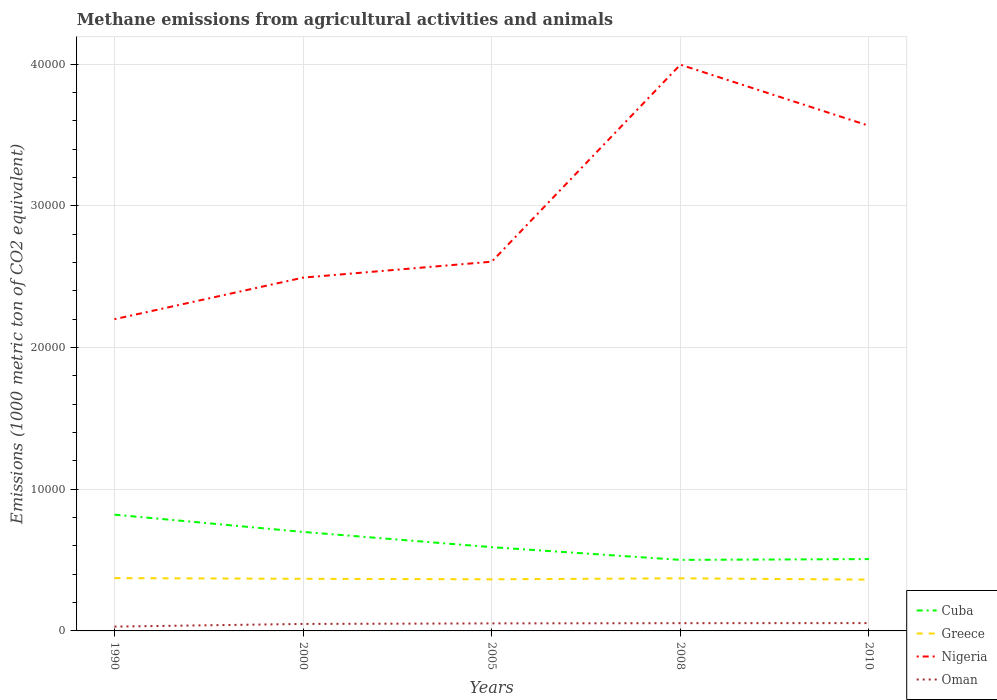How many different coloured lines are there?
Keep it short and to the point. 4. Across all years, what is the maximum amount of methane emitted in Greece?
Keep it short and to the point. 3622.4. In which year was the amount of methane emitted in Oman maximum?
Provide a succinct answer. 1990. What is the total amount of methane emitted in Cuba in the graph?
Your answer should be compact. 1074.5. What is the difference between the highest and the second highest amount of methane emitted in Cuba?
Give a very brief answer. 3192.5. What is the difference between the highest and the lowest amount of methane emitted in Nigeria?
Offer a very short reply. 2. How many lines are there?
Make the answer very short. 4. How many years are there in the graph?
Ensure brevity in your answer.  5. Are the values on the major ticks of Y-axis written in scientific E-notation?
Provide a succinct answer. No. Where does the legend appear in the graph?
Your answer should be very brief. Bottom right. How are the legend labels stacked?
Make the answer very short. Vertical. What is the title of the graph?
Ensure brevity in your answer.  Methane emissions from agricultural activities and animals. Does "Heavily indebted poor countries" appear as one of the legend labels in the graph?
Provide a succinct answer. No. What is the label or title of the Y-axis?
Ensure brevity in your answer.  Emissions (1000 metric ton of CO2 equivalent). What is the Emissions (1000 metric ton of CO2 equivalent) of Cuba in 1990?
Your answer should be very brief. 8207.5. What is the Emissions (1000 metric ton of CO2 equivalent) in Greece in 1990?
Offer a terse response. 3728.5. What is the Emissions (1000 metric ton of CO2 equivalent) of Nigeria in 1990?
Offer a very short reply. 2.20e+04. What is the Emissions (1000 metric ton of CO2 equivalent) in Oman in 1990?
Provide a succinct answer. 305.6. What is the Emissions (1000 metric ton of CO2 equivalent) of Cuba in 2000?
Offer a very short reply. 6988.3. What is the Emissions (1000 metric ton of CO2 equivalent) in Greece in 2000?
Your answer should be very brief. 3679.3. What is the Emissions (1000 metric ton of CO2 equivalent) in Nigeria in 2000?
Ensure brevity in your answer.  2.49e+04. What is the Emissions (1000 metric ton of CO2 equivalent) of Oman in 2000?
Your answer should be very brief. 493.2. What is the Emissions (1000 metric ton of CO2 equivalent) in Cuba in 2005?
Offer a terse response. 5913.8. What is the Emissions (1000 metric ton of CO2 equivalent) in Greece in 2005?
Provide a short and direct response. 3644.6. What is the Emissions (1000 metric ton of CO2 equivalent) of Nigeria in 2005?
Make the answer very short. 2.61e+04. What is the Emissions (1000 metric ton of CO2 equivalent) of Oman in 2005?
Your response must be concise. 531.8. What is the Emissions (1000 metric ton of CO2 equivalent) in Cuba in 2008?
Offer a very short reply. 5015. What is the Emissions (1000 metric ton of CO2 equivalent) in Greece in 2008?
Your answer should be compact. 3714.1. What is the Emissions (1000 metric ton of CO2 equivalent) in Nigeria in 2008?
Your answer should be compact. 4.00e+04. What is the Emissions (1000 metric ton of CO2 equivalent) in Oman in 2008?
Your answer should be compact. 546.4. What is the Emissions (1000 metric ton of CO2 equivalent) of Cuba in 2010?
Provide a short and direct response. 5070.2. What is the Emissions (1000 metric ton of CO2 equivalent) in Greece in 2010?
Provide a short and direct response. 3622.4. What is the Emissions (1000 metric ton of CO2 equivalent) of Nigeria in 2010?
Provide a succinct answer. 3.57e+04. What is the Emissions (1000 metric ton of CO2 equivalent) in Oman in 2010?
Offer a terse response. 551.8. Across all years, what is the maximum Emissions (1000 metric ton of CO2 equivalent) of Cuba?
Make the answer very short. 8207.5. Across all years, what is the maximum Emissions (1000 metric ton of CO2 equivalent) of Greece?
Offer a very short reply. 3728.5. Across all years, what is the maximum Emissions (1000 metric ton of CO2 equivalent) of Nigeria?
Ensure brevity in your answer.  4.00e+04. Across all years, what is the maximum Emissions (1000 metric ton of CO2 equivalent) of Oman?
Keep it short and to the point. 551.8. Across all years, what is the minimum Emissions (1000 metric ton of CO2 equivalent) in Cuba?
Your response must be concise. 5015. Across all years, what is the minimum Emissions (1000 metric ton of CO2 equivalent) in Greece?
Offer a very short reply. 3622.4. Across all years, what is the minimum Emissions (1000 metric ton of CO2 equivalent) of Nigeria?
Your answer should be compact. 2.20e+04. Across all years, what is the minimum Emissions (1000 metric ton of CO2 equivalent) in Oman?
Your answer should be compact. 305.6. What is the total Emissions (1000 metric ton of CO2 equivalent) of Cuba in the graph?
Your answer should be very brief. 3.12e+04. What is the total Emissions (1000 metric ton of CO2 equivalent) in Greece in the graph?
Offer a terse response. 1.84e+04. What is the total Emissions (1000 metric ton of CO2 equivalent) in Nigeria in the graph?
Your answer should be compact. 1.49e+05. What is the total Emissions (1000 metric ton of CO2 equivalent) in Oman in the graph?
Make the answer very short. 2428.8. What is the difference between the Emissions (1000 metric ton of CO2 equivalent) in Cuba in 1990 and that in 2000?
Provide a short and direct response. 1219.2. What is the difference between the Emissions (1000 metric ton of CO2 equivalent) of Greece in 1990 and that in 2000?
Ensure brevity in your answer.  49.2. What is the difference between the Emissions (1000 metric ton of CO2 equivalent) in Nigeria in 1990 and that in 2000?
Offer a very short reply. -2935.6. What is the difference between the Emissions (1000 metric ton of CO2 equivalent) in Oman in 1990 and that in 2000?
Provide a succinct answer. -187.6. What is the difference between the Emissions (1000 metric ton of CO2 equivalent) of Cuba in 1990 and that in 2005?
Ensure brevity in your answer.  2293.7. What is the difference between the Emissions (1000 metric ton of CO2 equivalent) in Greece in 1990 and that in 2005?
Offer a very short reply. 83.9. What is the difference between the Emissions (1000 metric ton of CO2 equivalent) in Nigeria in 1990 and that in 2005?
Offer a terse response. -4059.4. What is the difference between the Emissions (1000 metric ton of CO2 equivalent) in Oman in 1990 and that in 2005?
Your answer should be compact. -226.2. What is the difference between the Emissions (1000 metric ton of CO2 equivalent) in Cuba in 1990 and that in 2008?
Keep it short and to the point. 3192.5. What is the difference between the Emissions (1000 metric ton of CO2 equivalent) in Greece in 1990 and that in 2008?
Give a very brief answer. 14.4. What is the difference between the Emissions (1000 metric ton of CO2 equivalent) in Nigeria in 1990 and that in 2008?
Your answer should be very brief. -1.80e+04. What is the difference between the Emissions (1000 metric ton of CO2 equivalent) of Oman in 1990 and that in 2008?
Keep it short and to the point. -240.8. What is the difference between the Emissions (1000 metric ton of CO2 equivalent) of Cuba in 1990 and that in 2010?
Your response must be concise. 3137.3. What is the difference between the Emissions (1000 metric ton of CO2 equivalent) of Greece in 1990 and that in 2010?
Offer a very short reply. 106.1. What is the difference between the Emissions (1000 metric ton of CO2 equivalent) in Nigeria in 1990 and that in 2010?
Your answer should be very brief. -1.37e+04. What is the difference between the Emissions (1000 metric ton of CO2 equivalent) in Oman in 1990 and that in 2010?
Your answer should be very brief. -246.2. What is the difference between the Emissions (1000 metric ton of CO2 equivalent) of Cuba in 2000 and that in 2005?
Your answer should be compact. 1074.5. What is the difference between the Emissions (1000 metric ton of CO2 equivalent) of Greece in 2000 and that in 2005?
Provide a short and direct response. 34.7. What is the difference between the Emissions (1000 metric ton of CO2 equivalent) of Nigeria in 2000 and that in 2005?
Make the answer very short. -1123.8. What is the difference between the Emissions (1000 metric ton of CO2 equivalent) in Oman in 2000 and that in 2005?
Make the answer very short. -38.6. What is the difference between the Emissions (1000 metric ton of CO2 equivalent) of Cuba in 2000 and that in 2008?
Your response must be concise. 1973.3. What is the difference between the Emissions (1000 metric ton of CO2 equivalent) in Greece in 2000 and that in 2008?
Ensure brevity in your answer.  -34.8. What is the difference between the Emissions (1000 metric ton of CO2 equivalent) of Nigeria in 2000 and that in 2008?
Offer a terse response. -1.50e+04. What is the difference between the Emissions (1000 metric ton of CO2 equivalent) in Oman in 2000 and that in 2008?
Make the answer very short. -53.2. What is the difference between the Emissions (1000 metric ton of CO2 equivalent) in Cuba in 2000 and that in 2010?
Provide a short and direct response. 1918.1. What is the difference between the Emissions (1000 metric ton of CO2 equivalent) in Greece in 2000 and that in 2010?
Offer a very short reply. 56.9. What is the difference between the Emissions (1000 metric ton of CO2 equivalent) in Nigeria in 2000 and that in 2010?
Make the answer very short. -1.07e+04. What is the difference between the Emissions (1000 metric ton of CO2 equivalent) of Oman in 2000 and that in 2010?
Offer a terse response. -58.6. What is the difference between the Emissions (1000 metric ton of CO2 equivalent) of Cuba in 2005 and that in 2008?
Give a very brief answer. 898.8. What is the difference between the Emissions (1000 metric ton of CO2 equivalent) of Greece in 2005 and that in 2008?
Provide a succinct answer. -69.5. What is the difference between the Emissions (1000 metric ton of CO2 equivalent) of Nigeria in 2005 and that in 2008?
Your response must be concise. -1.39e+04. What is the difference between the Emissions (1000 metric ton of CO2 equivalent) of Oman in 2005 and that in 2008?
Your response must be concise. -14.6. What is the difference between the Emissions (1000 metric ton of CO2 equivalent) of Cuba in 2005 and that in 2010?
Give a very brief answer. 843.6. What is the difference between the Emissions (1000 metric ton of CO2 equivalent) of Greece in 2005 and that in 2010?
Your response must be concise. 22.2. What is the difference between the Emissions (1000 metric ton of CO2 equivalent) of Nigeria in 2005 and that in 2010?
Your answer should be very brief. -9593.8. What is the difference between the Emissions (1000 metric ton of CO2 equivalent) in Cuba in 2008 and that in 2010?
Offer a terse response. -55.2. What is the difference between the Emissions (1000 metric ton of CO2 equivalent) of Greece in 2008 and that in 2010?
Your response must be concise. 91.7. What is the difference between the Emissions (1000 metric ton of CO2 equivalent) of Nigeria in 2008 and that in 2010?
Your response must be concise. 4315.8. What is the difference between the Emissions (1000 metric ton of CO2 equivalent) of Cuba in 1990 and the Emissions (1000 metric ton of CO2 equivalent) of Greece in 2000?
Offer a terse response. 4528.2. What is the difference between the Emissions (1000 metric ton of CO2 equivalent) in Cuba in 1990 and the Emissions (1000 metric ton of CO2 equivalent) in Nigeria in 2000?
Give a very brief answer. -1.67e+04. What is the difference between the Emissions (1000 metric ton of CO2 equivalent) of Cuba in 1990 and the Emissions (1000 metric ton of CO2 equivalent) of Oman in 2000?
Keep it short and to the point. 7714.3. What is the difference between the Emissions (1000 metric ton of CO2 equivalent) in Greece in 1990 and the Emissions (1000 metric ton of CO2 equivalent) in Nigeria in 2000?
Keep it short and to the point. -2.12e+04. What is the difference between the Emissions (1000 metric ton of CO2 equivalent) in Greece in 1990 and the Emissions (1000 metric ton of CO2 equivalent) in Oman in 2000?
Provide a succinct answer. 3235.3. What is the difference between the Emissions (1000 metric ton of CO2 equivalent) in Nigeria in 1990 and the Emissions (1000 metric ton of CO2 equivalent) in Oman in 2000?
Provide a short and direct response. 2.15e+04. What is the difference between the Emissions (1000 metric ton of CO2 equivalent) in Cuba in 1990 and the Emissions (1000 metric ton of CO2 equivalent) in Greece in 2005?
Make the answer very short. 4562.9. What is the difference between the Emissions (1000 metric ton of CO2 equivalent) in Cuba in 1990 and the Emissions (1000 metric ton of CO2 equivalent) in Nigeria in 2005?
Your answer should be very brief. -1.79e+04. What is the difference between the Emissions (1000 metric ton of CO2 equivalent) of Cuba in 1990 and the Emissions (1000 metric ton of CO2 equivalent) of Oman in 2005?
Provide a succinct answer. 7675.7. What is the difference between the Emissions (1000 metric ton of CO2 equivalent) in Greece in 1990 and the Emissions (1000 metric ton of CO2 equivalent) in Nigeria in 2005?
Make the answer very short. -2.23e+04. What is the difference between the Emissions (1000 metric ton of CO2 equivalent) in Greece in 1990 and the Emissions (1000 metric ton of CO2 equivalent) in Oman in 2005?
Ensure brevity in your answer.  3196.7. What is the difference between the Emissions (1000 metric ton of CO2 equivalent) of Nigeria in 1990 and the Emissions (1000 metric ton of CO2 equivalent) of Oman in 2005?
Offer a very short reply. 2.15e+04. What is the difference between the Emissions (1000 metric ton of CO2 equivalent) of Cuba in 1990 and the Emissions (1000 metric ton of CO2 equivalent) of Greece in 2008?
Provide a short and direct response. 4493.4. What is the difference between the Emissions (1000 metric ton of CO2 equivalent) of Cuba in 1990 and the Emissions (1000 metric ton of CO2 equivalent) of Nigeria in 2008?
Offer a terse response. -3.18e+04. What is the difference between the Emissions (1000 metric ton of CO2 equivalent) in Cuba in 1990 and the Emissions (1000 metric ton of CO2 equivalent) in Oman in 2008?
Your answer should be very brief. 7661.1. What is the difference between the Emissions (1000 metric ton of CO2 equivalent) of Greece in 1990 and the Emissions (1000 metric ton of CO2 equivalent) of Nigeria in 2008?
Keep it short and to the point. -3.62e+04. What is the difference between the Emissions (1000 metric ton of CO2 equivalent) in Greece in 1990 and the Emissions (1000 metric ton of CO2 equivalent) in Oman in 2008?
Provide a succinct answer. 3182.1. What is the difference between the Emissions (1000 metric ton of CO2 equivalent) of Nigeria in 1990 and the Emissions (1000 metric ton of CO2 equivalent) of Oman in 2008?
Provide a succinct answer. 2.15e+04. What is the difference between the Emissions (1000 metric ton of CO2 equivalent) of Cuba in 1990 and the Emissions (1000 metric ton of CO2 equivalent) of Greece in 2010?
Ensure brevity in your answer.  4585.1. What is the difference between the Emissions (1000 metric ton of CO2 equivalent) in Cuba in 1990 and the Emissions (1000 metric ton of CO2 equivalent) in Nigeria in 2010?
Provide a short and direct response. -2.75e+04. What is the difference between the Emissions (1000 metric ton of CO2 equivalent) in Cuba in 1990 and the Emissions (1000 metric ton of CO2 equivalent) in Oman in 2010?
Your response must be concise. 7655.7. What is the difference between the Emissions (1000 metric ton of CO2 equivalent) in Greece in 1990 and the Emissions (1000 metric ton of CO2 equivalent) in Nigeria in 2010?
Your answer should be compact. -3.19e+04. What is the difference between the Emissions (1000 metric ton of CO2 equivalent) of Greece in 1990 and the Emissions (1000 metric ton of CO2 equivalent) of Oman in 2010?
Give a very brief answer. 3176.7. What is the difference between the Emissions (1000 metric ton of CO2 equivalent) of Nigeria in 1990 and the Emissions (1000 metric ton of CO2 equivalent) of Oman in 2010?
Keep it short and to the point. 2.15e+04. What is the difference between the Emissions (1000 metric ton of CO2 equivalent) of Cuba in 2000 and the Emissions (1000 metric ton of CO2 equivalent) of Greece in 2005?
Keep it short and to the point. 3343.7. What is the difference between the Emissions (1000 metric ton of CO2 equivalent) of Cuba in 2000 and the Emissions (1000 metric ton of CO2 equivalent) of Nigeria in 2005?
Your answer should be compact. -1.91e+04. What is the difference between the Emissions (1000 metric ton of CO2 equivalent) in Cuba in 2000 and the Emissions (1000 metric ton of CO2 equivalent) in Oman in 2005?
Your answer should be compact. 6456.5. What is the difference between the Emissions (1000 metric ton of CO2 equivalent) in Greece in 2000 and the Emissions (1000 metric ton of CO2 equivalent) in Nigeria in 2005?
Your answer should be compact. -2.24e+04. What is the difference between the Emissions (1000 metric ton of CO2 equivalent) in Greece in 2000 and the Emissions (1000 metric ton of CO2 equivalent) in Oman in 2005?
Give a very brief answer. 3147.5. What is the difference between the Emissions (1000 metric ton of CO2 equivalent) of Nigeria in 2000 and the Emissions (1000 metric ton of CO2 equivalent) of Oman in 2005?
Provide a succinct answer. 2.44e+04. What is the difference between the Emissions (1000 metric ton of CO2 equivalent) in Cuba in 2000 and the Emissions (1000 metric ton of CO2 equivalent) in Greece in 2008?
Make the answer very short. 3274.2. What is the difference between the Emissions (1000 metric ton of CO2 equivalent) of Cuba in 2000 and the Emissions (1000 metric ton of CO2 equivalent) of Nigeria in 2008?
Offer a very short reply. -3.30e+04. What is the difference between the Emissions (1000 metric ton of CO2 equivalent) in Cuba in 2000 and the Emissions (1000 metric ton of CO2 equivalent) in Oman in 2008?
Your answer should be very brief. 6441.9. What is the difference between the Emissions (1000 metric ton of CO2 equivalent) of Greece in 2000 and the Emissions (1000 metric ton of CO2 equivalent) of Nigeria in 2008?
Make the answer very short. -3.63e+04. What is the difference between the Emissions (1000 metric ton of CO2 equivalent) of Greece in 2000 and the Emissions (1000 metric ton of CO2 equivalent) of Oman in 2008?
Keep it short and to the point. 3132.9. What is the difference between the Emissions (1000 metric ton of CO2 equivalent) in Nigeria in 2000 and the Emissions (1000 metric ton of CO2 equivalent) in Oman in 2008?
Your answer should be very brief. 2.44e+04. What is the difference between the Emissions (1000 metric ton of CO2 equivalent) of Cuba in 2000 and the Emissions (1000 metric ton of CO2 equivalent) of Greece in 2010?
Your response must be concise. 3365.9. What is the difference between the Emissions (1000 metric ton of CO2 equivalent) of Cuba in 2000 and the Emissions (1000 metric ton of CO2 equivalent) of Nigeria in 2010?
Your response must be concise. -2.87e+04. What is the difference between the Emissions (1000 metric ton of CO2 equivalent) of Cuba in 2000 and the Emissions (1000 metric ton of CO2 equivalent) of Oman in 2010?
Offer a very short reply. 6436.5. What is the difference between the Emissions (1000 metric ton of CO2 equivalent) of Greece in 2000 and the Emissions (1000 metric ton of CO2 equivalent) of Nigeria in 2010?
Make the answer very short. -3.20e+04. What is the difference between the Emissions (1000 metric ton of CO2 equivalent) in Greece in 2000 and the Emissions (1000 metric ton of CO2 equivalent) in Oman in 2010?
Give a very brief answer. 3127.5. What is the difference between the Emissions (1000 metric ton of CO2 equivalent) in Nigeria in 2000 and the Emissions (1000 metric ton of CO2 equivalent) in Oman in 2010?
Make the answer very short. 2.44e+04. What is the difference between the Emissions (1000 metric ton of CO2 equivalent) in Cuba in 2005 and the Emissions (1000 metric ton of CO2 equivalent) in Greece in 2008?
Give a very brief answer. 2199.7. What is the difference between the Emissions (1000 metric ton of CO2 equivalent) in Cuba in 2005 and the Emissions (1000 metric ton of CO2 equivalent) in Nigeria in 2008?
Your answer should be compact. -3.41e+04. What is the difference between the Emissions (1000 metric ton of CO2 equivalent) of Cuba in 2005 and the Emissions (1000 metric ton of CO2 equivalent) of Oman in 2008?
Offer a very short reply. 5367.4. What is the difference between the Emissions (1000 metric ton of CO2 equivalent) of Greece in 2005 and the Emissions (1000 metric ton of CO2 equivalent) of Nigeria in 2008?
Your answer should be compact. -3.63e+04. What is the difference between the Emissions (1000 metric ton of CO2 equivalent) in Greece in 2005 and the Emissions (1000 metric ton of CO2 equivalent) in Oman in 2008?
Your answer should be compact. 3098.2. What is the difference between the Emissions (1000 metric ton of CO2 equivalent) of Nigeria in 2005 and the Emissions (1000 metric ton of CO2 equivalent) of Oman in 2008?
Make the answer very short. 2.55e+04. What is the difference between the Emissions (1000 metric ton of CO2 equivalent) of Cuba in 2005 and the Emissions (1000 metric ton of CO2 equivalent) of Greece in 2010?
Ensure brevity in your answer.  2291.4. What is the difference between the Emissions (1000 metric ton of CO2 equivalent) in Cuba in 2005 and the Emissions (1000 metric ton of CO2 equivalent) in Nigeria in 2010?
Your response must be concise. -2.97e+04. What is the difference between the Emissions (1000 metric ton of CO2 equivalent) in Cuba in 2005 and the Emissions (1000 metric ton of CO2 equivalent) in Oman in 2010?
Offer a very short reply. 5362. What is the difference between the Emissions (1000 metric ton of CO2 equivalent) in Greece in 2005 and the Emissions (1000 metric ton of CO2 equivalent) in Nigeria in 2010?
Give a very brief answer. -3.20e+04. What is the difference between the Emissions (1000 metric ton of CO2 equivalent) of Greece in 2005 and the Emissions (1000 metric ton of CO2 equivalent) of Oman in 2010?
Give a very brief answer. 3092.8. What is the difference between the Emissions (1000 metric ton of CO2 equivalent) in Nigeria in 2005 and the Emissions (1000 metric ton of CO2 equivalent) in Oman in 2010?
Make the answer very short. 2.55e+04. What is the difference between the Emissions (1000 metric ton of CO2 equivalent) of Cuba in 2008 and the Emissions (1000 metric ton of CO2 equivalent) of Greece in 2010?
Your answer should be very brief. 1392.6. What is the difference between the Emissions (1000 metric ton of CO2 equivalent) in Cuba in 2008 and the Emissions (1000 metric ton of CO2 equivalent) in Nigeria in 2010?
Offer a very short reply. -3.06e+04. What is the difference between the Emissions (1000 metric ton of CO2 equivalent) of Cuba in 2008 and the Emissions (1000 metric ton of CO2 equivalent) of Oman in 2010?
Your response must be concise. 4463.2. What is the difference between the Emissions (1000 metric ton of CO2 equivalent) in Greece in 2008 and the Emissions (1000 metric ton of CO2 equivalent) in Nigeria in 2010?
Your response must be concise. -3.19e+04. What is the difference between the Emissions (1000 metric ton of CO2 equivalent) in Greece in 2008 and the Emissions (1000 metric ton of CO2 equivalent) in Oman in 2010?
Ensure brevity in your answer.  3162.3. What is the difference between the Emissions (1000 metric ton of CO2 equivalent) in Nigeria in 2008 and the Emissions (1000 metric ton of CO2 equivalent) in Oman in 2010?
Offer a terse response. 3.94e+04. What is the average Emissions (1000 metric ton of CO2 equivalent) in Cuba per year?
Your answer should be compact. 6238.96. What is the average Emissions (1000 metric ton of CO2 equivalent) of Greece per year?
Your response must be concise. 3677.78. What is the average Emissions (1000 metric ton of CO2 equivalent) in Nigeria per year?
Offer a very short reply. 2.97e+04. What is the average Emissions (1000 metric ton of CO2 equivalent) in Oman per year?
Provide a short and direct response. 485.76. In the year 1990, what is the difference between the Emissions (1000 metric ton of CO2 equivalent) in Cuba and Emissions (1000 metric ton of CO2 equivalent) in Greece?
Ensure brevity in your answer.  4479. In the year 1990, what is the difference between the Emissions (1000 metric ton of CO2 equivalent) in Cuba and Emissions (1000 metric ton of CO2 equivalent) in Nigeria?
Your answer should be compact. -1.38e+04. In the year 1990, what is the difference between the Emissions (1000 metric ton of CO2 equivalent) of Cuba and Emissions (1000 metric ton of CO2 equivalent) of Oman?
Make the answer very short. 7901.9. In the year 1990, what is the difference between the Emissions (1000 metric ton of CO2 equivalent) of Greece and Emissions (1000 metric ton of CO2 equivalent) of Nigeria?
Provide a succinct answer. -1.83e+04. In the year 1990, what is the difference between the Emissions (1000 metric ton of CO2 equivalent) of Greece and Emissions (1000 metric ton of CO2 equivalent) of Oman?
Make the answer very short. 3422.9. In the year 1990, what is the difference between the Emissions (1000 metric ton of CO2 equivalent) in Nigeria and Emissions (1000 metric ton of CO2 equivalent) in Oman?
Provide a succinct answer. 2.17e+04. In the year 2000, what is the difference between the Emissions (1000 metric ton of CO2 equivalent) of Cuba and Emissions (1000 metric ton of CO2 equivalent) of Greece?
Ensure brevity in your answer.  3309. In the year 2000, what is the difference between the Emissions (1000 metric ton of CO2 equivalent) in Cuba and Emissions (1000 metric ton of CO2 equivalent) in Nigeria?
Your answer should be very brief. -1.80e+04. In the year 2000, what is the difference between the Emissions (1000 metric ton of CO2 equivalent) of Cuba and Emissions (1000 metric ton of CO2 equivalent) of Oman?
Make the answer very short. 6495.1. In the year 2000, what is the difference between the Emissions (1000 metric ton of CO2 equivalent) in Greece and Emissions (1000 metric ton of CO2 equivalent) in Nigeria?
Your response must be concise. -2.13e+04. In the year 2000, what is the difference between the Emissions (1000 metric ton of CO2 equivalent) in Greece and Emissions (1000 metric ton of CO2 equivalent) in Oman?
Make the answer very short. 3186.1. In the year 2000, what is the difference between the Emissions (1000 metric ton of CO2 equivalent) in Nigeria and Emissions (1000 metric ton of CO2 equivalent) in Oman?
Make the answer very short. 2.44e+04. In the year 2005, what is the difference between the Emissions (1000 metric ton of CO2 equivalent) in Cuba and Emissions (1000 metric ton of CO2 equivalent) in Greece?
Provide a succinct answer. 2269.2. In the year 2005, what is the difference between the Emissions (1000 metric ton of CO2 equivalent) in Cuba and Emissions (1000 metric ton of CO2 equivalent) in Nigeria?
Offer a very short reply. -2.02e+04. In the year 2005, what is the difference between the Emissions (1000 metric ton of CO2 equivalent) in Cuba and Emissions (1000 metric ton of CO2 equivalent) in Oman?
Ensure brevity in your answer.  5382. In the year 2005, what is the difference between the Emissions (1000 metric ton of CO2 equivalent) in Greece and Emissions (1000 metric ton of CO2 equivalent) in Nigeria?
Offer a very short reply. -2.24e+04. In the year 2005, what is the difference between the Emissions (1000 metric ton of CO2 equivalent) in Greece and Emissions (1000 metric ton of CO2 equivalent) in Oman?
Provide a succinct answer. 3112.8. In the year 2005, what is the difference between the Emissions (1000 metric ton of CO2 equivalent) in Nigeria and Emissions (1000 metric ton of CO2 equivalent) in Oman?
Offer a very short reply. 2.55e+04. In the year 2008, what is the difference between the Emissions (1000 metric ton of CO2 equivalent) of Cuba and Emissions (1000 metric ton of CO2 equivalent) of Greece?
Provide a short and direct response. 1300.9. In the year 2008, what is the difference between the Emissions (1000 metric ton of CO2 equivalent) of Cuba and Emissions (1000 metric ton of CO2 equivalent) of Nigeria?
Your response must be concise. -3.50e+04. In the year 2008, what is the difference between the Emissions (1000 metric ton of CO2 equivalent) in Cuba and Emissions (1000 metric ton of CO2 equivalent) in Oman?
Your answer should be compact. 4468.6. In the year 2008, what is the difference between the Emissions (1000 metric ton of CO2 equivalent) in Greece and Emissions (1000 metric ton of CO2 equivalent) in Nigeria?
Provide a short and direct response. -3.63e+04. In the year 2008, what is the difference between the Emissions (1000 metric ton of CO2 equivalent) of Greece and Emissions (1000 metric ton of CO2 equivalent) of Oman?
Offer a very short reply. 3167.7. In the year 2008, what is the difference between the Emissions (1000 metric ton of CO2 equivalent) of Nigeria and Emissions (1000 metric ton of CO2 equivalent) of Oman?
Provide a succinct answer. 3.94e+04. In the year 2010, what is the difference between the Emissions (1000 metric ton of CO2 equivalent) in Cuba and Emissions (1000 metric ton of CO2 equivalent) in Greece?
Ensure brevity in your answer.  1447.8. In the year 2010, what is the difference between the Emissions (1000 metric ton of CO2 equivalent) of Cuba and Emissions (1000 metric ton of CO2 equivalent) of Nigeria?
Your response must be concise. -3.06e+04. In the year 2010, what is the difference between the Emissions (1000 metric ton of CO2 equivalent) of Cuba and Emissions (1000 metric ton of CO2 equivalent) of Oman?
Your answer should be very brief. 4518.4. In the year 2010, what is the difference between the Emissions (1000 metric ton of CO2 equivalent) of Greece and Emissions (1000 metric ton of CO2 equivalent) of Nigeria?
Make the answer very short. -3.20e+04. In the year 2010, what is the difference between the Emissions (1000 metric ton of CO2 equivalent) in Greece and Emissions (1000 metric ton of CO2 equivalent) in Oman?
Offer a very short reply. 3070.6. In the year 2010, what is the difference between the Emissions (1000 metric ton of CO2 equivalent) of Nigeria and Emissions (1000 metric ton of CO2 equivalent) of Oman?
Your answer should be compact. 3.51e+04. What is the ratio of the Emissions (1000 metric ton of CO2 equivalent) in Cuba in 1990 to that in 2000?
Your answer should be compact. 1.17. What is the ratio of the Emissions (1000 metric ton of CO2 equivalent) in Greece in 1990 to that in 2000?
Offer a very short reply. 1.01. What is the ratio of the Emissions (1000 metric ton of CO2 equivalent) of Nigeria in 1990 to that in 2000?
Provide a short and direct response. 0.88. What is the ratio of the Emissions (1000 metric ton of CO2 equivalent) of Oman in 1990 to that in 2000?
Make the answer very short. 0.62. What is the ratio of the Emissions (1000 metric ton of CO2 equivalent) of Cuba in 1990 to that in 2005?
Provide a succinct answer. 1.39. What is the ratio of the Emissions (1000 metric ton of CO2 equivalent) of Greece in 1990 to that in 2005?
Keep it short and to the point. 1.02. What is the ratio of the Emissions (1000 metric ton of CO2 equivalent) of Nigeria in 1990 to that in 2005?
Provide a succinct answer. 0.84. What is the ratio of the Emissions (1000 metric ton of CO2 equivalent) in Oman in 1990 to that in 2005?
Offer a very short reply. 0.57. What is the ratio of the Emissions (1000 metric ton of CO2 equivalent) in Cuba in 1990 to that in 2008?
Provide a short and direct response. 1.64. What is the ratio of the Emissions (1000 metric ton of CO2 equivalent) of Nigeria in 1990 to that in 2008?
Make the answer very short. 0.55. What is the ratio of the Emissions (1000 metric ton of CO2 equivalent) in Oman in 1990 to that in 2008?
Provide a short and direct response. 0.56. What is the ratio of the Emissions (1000 metric ton of CO2 equivalent) in Cuba in 1990 to that in 2010?
Provide a short and direct response. 1.62. What is the ratio of the Emissions (1000 metric ton of CO2 equivalent) in Greece in 1990 to that in 2010?
Your answer should be very brief. 1.03. What is the ratio of the Emissions (1000 metric ton of CO2 equivalent) in Nigeria in 1990 to that in 2010?
Your answer should be very brief. 0.62. What is the ratio of the Emissions (1000 metric ton of CO2 equivalent) of Oman in 1990 to that in 2010?
Provide a succinct answer. 0.55. What is the ratio of the Emissions (1000 metric ton of CO2 equivalent) of Cuba in 2000 to that in 2005?
Ensure brevity in your answer.  1.18. What is the ratio of the Emissions (1000 metric ton of CO2 equivalent) of Greece in 2000 to that in 2005?
Make the answer very short. 1.01. What is the ratio of the Emissions (1000 metric ton of CO2 equivalent) of Nigeria in 2000 to that in 2005?
Provide a succinct answer. 0.96. What is the ratio of the Emissions (1000 metric ton of CO2 equivalent) in Oman in 2000 to that in 2005?
Keep it short and to the point. 0.93. What is the ratio of the Emissions (1000 metric ton of CO2 equivalent) of Cuba in 2000 to that in 2008?
Make the answer very short. 1.39. What is the ratio of the Emissions (1000 metric ton of CO2 equivalent) of Greece in 2000 to that in 2008?
Offer a very short reply. 0.99. What is the ratio of the Emissions (1000 metric ton of CO2 equivalent) of Nigeria in 2000 to that in 2008?
Provide a short and direct response. 0.62. What is the ratio of the Emissions (1000 metric ton of CO2 equivalent) in Oman in 2000 to that in 2008?
Give a very brief answer. 0.9. What is the ratio of the Emissions (1000 metric ton of CO2 equivalent) in Cuba in 2000 to that in 2010?
Offer a terse response. 1.38. What is the ratio of the Emissions (1000 metric ton of CO2 equivalent) of Greece in 2000 to that in 2010?
Give a very brief answer. 1.02. What is the ratio of the Emissions (1000 metric ton of CO2 equivalent) in Nigeria in 2000 to that in 2010?
Keep it short and to the point. 0.7. What is the ratio of the Emissions (1000 metric ton of CO2 equivalent) in Oman in 2000 to that in 2010?
Offer a very short reply. 0.89. What is the ratio of the Emissions (1000 metric ton of CO2 equivalent) of Cuba in 2005 to that in 2008?
Offer a terse response. 1.18. What is the ratio of the Emissions (1000 metric ton of CO2 equivalent) of Greece in 2005 to that in 2008?
Provide a short and direct response. 0.98. What is the ratio of the Emissions (1000 metric ton of CO2 equivalent) of Nigeria in 2005 to that in 2008?
Give a very brief answer. 0.65. What is the ratio of the Emissions (1000 metric ton of CO2 equivalent) of Oman in 2005 to that in 2008?
Your answer should be very brief. 0.97. What is the ratio of the Emissions (1000 metric ton of CO2 equivalent) in Cuba in 2005 to that in 2010?
Your answer should be compact. 1.17. What is the ratio of the Emissions (1000 metric ton of CO2 equivalent) of Nigeria in 2005 to that in 2010?
Your answer should be compact. 0.73. What is the ratio of the Emissions (1000 metric ton of CO2 equivalent) of Oman in 2005 to that in 2010?
Make the answer very short. 0.96. What is the ratio of the Emissions (1000 metric ton of CO2 equivalent) of Greece in 2008 to that in 2010?
Give a very brief answer. 1.03. What is the ratio of the Emissions (1000 metric ton of CO2 equivalent) of Nigeria in 2008 to that in 2010?
Make the answer very short. 1.12. What is the ratio of the Emissions (1000 metric ton of CO2 equivalent) of Oman in 2008 to that in 2010?
Ensure brevity in your answer.  0.99. What is the difference between the highest and the second highest Emissions (1000 metric ton of CO2 equivalent) of Cuba?
Give a very brief answer. 1219.2. What is the difference between the highest and the second highest Emissions (1000 metric ton of CO2 equivalent) in Greece?
Your answer should be very brief. 14.4. What is the difference between the highest and the second highest Emissions (1000 metric ton of CO2 equivalent) of Nigeria?
Your answer should be compact. 4315.8. What is the difference between the highest and the second highest Emissions (1000 metric ton of CO2 equivalent) in Oman?
Your response must be concise. 5.4. What is the difference between the highest and the lowest Emissions (1000 metric ton of CO2 equivalent) in Cuba?
Offer a terse response. 3192.5. What is the difference between the highest and the lowest Emissions (1000 metric ton of CO2 equivalent) in Greece?
Your answer should be compact. 106.1. What is the difference between the highest and the lowest Emissions (1000 metric ton of CO2 equivalent) of Nigeria?
Provide a succinct answer. 1.80e+04. What is the difference between the highest and the lowest Emissions (1000 metric ton of CO2 equivalent) of Oman?
Ensure brevity in your answer.  246.2. 